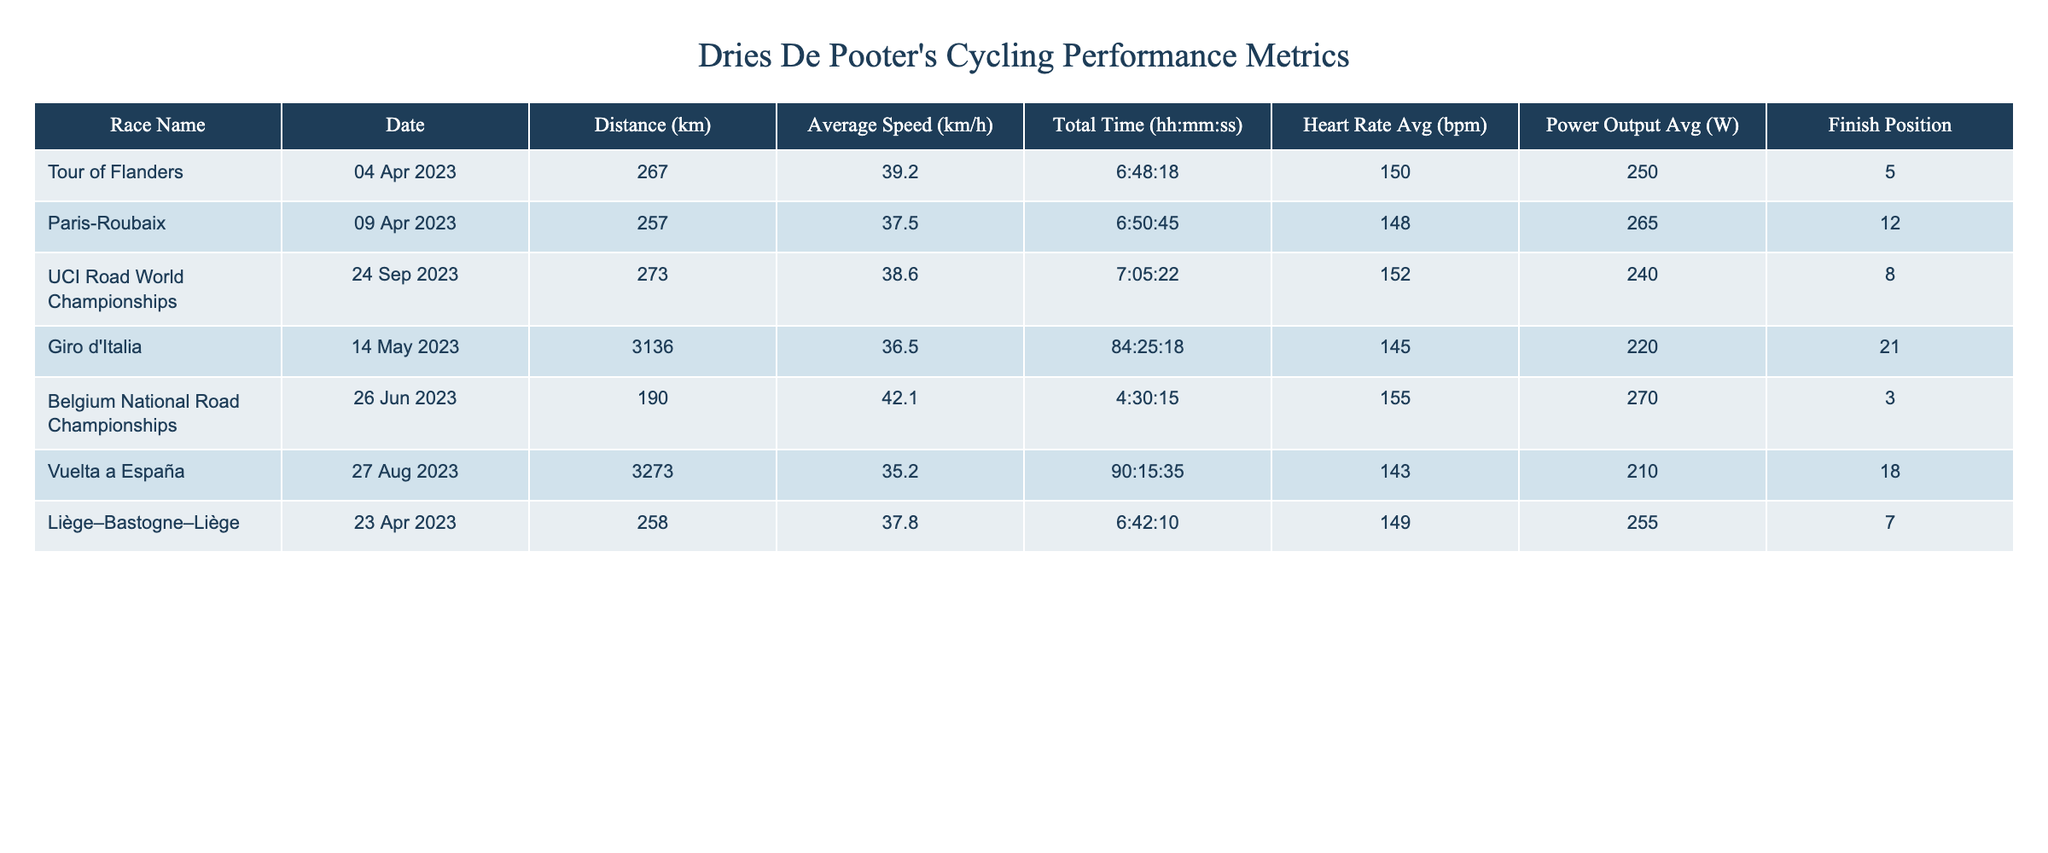What was the average speed of Dries De Pooter in the Tour of Flanders? The average speed for the Tour of Flanders is directly listed in the table as 39.2 km/h.
Answer: 39.2 km/h In which race did Dries De Pooter achieve his highest heart rate? By examining the heart rate averages, the highest heart rate listed is 155 bpm during the Belgium National Road Championships.
Answer: 155 bpm What is the total distance Dries De Pooter raced across all events listed? Adding all the distances from the table gives: 267 + 257 + 273 + 3136 + 190 + 3273 + 258 = 10400 km.
Answer: 10400 km Did Dries De Pooter finish in the top 10 in the UCI Road World Championships? He finished in position 8, which is within the top 10.
Answer: Yes What is the average power output across all events? First, sum the average power outputs: 250 + 265 + 240 + 220 + 270 + 210 + 255 = 1930 W. Then, divide by 7 (the number of events) to get the average: 1930 / 7 ≈ 275.7 W.
Answer: 275.7 W What was the finish position in the Giro d'Italia and how does it compare to his best finish position? In the Giro d'Italia, his finish position was 21, while his best position listed is 3 (from the Belgium National Road Championships). The comparison shows that 21 is significantly lower than 3.
Answer: 21 (comparison: lower) What race had the longest total time recorded for Dries De Pooter? The longest total time is 84:25:18, found in the Giro d'Italia.
Answer: Giro d'Italia How many races did Dries De Pooter finish outside the top 10? He finished outside the top 10 in Paris-Roubaix (12th), Giro d'Italia (21st), and Vuelta a España (18th), totaling 3 races.
Answer: 3 races What is the difference in average speed between the Belgium National Road Championships and the Vuelta a España? The average speed for the Belgium National Road Championships is 42.1 km/h and for the Vuelta a España it is 35.2 km/h. The difference is: 42.1 - 35.2 = 6.9 km/h.
Answer: 6.9 km/h 